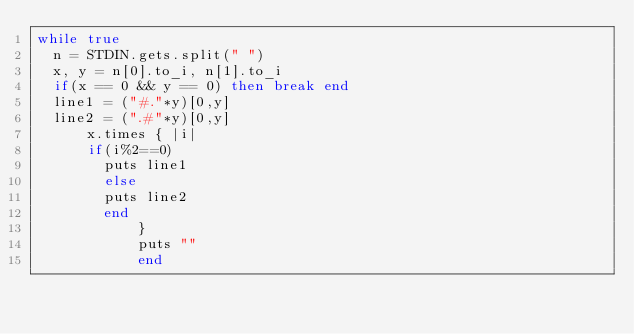Convert code to text. <code><loc_0><loc_0><loc_500><loc_500><_Ruby_>while true
  n = STDIN.gets.split(" ")
  x, y = n[0].to_i, n[1].to_i
  if(x == 0 && y == 0) then break end
  line1 = ("#."*y)[0,y]
  line2 = (".#"*y)[0,y]
      x.times { |i|
      if(i%2==0)
        puts line1
        else
        puts line2
        end
            }
            puts ""
            end</code> 